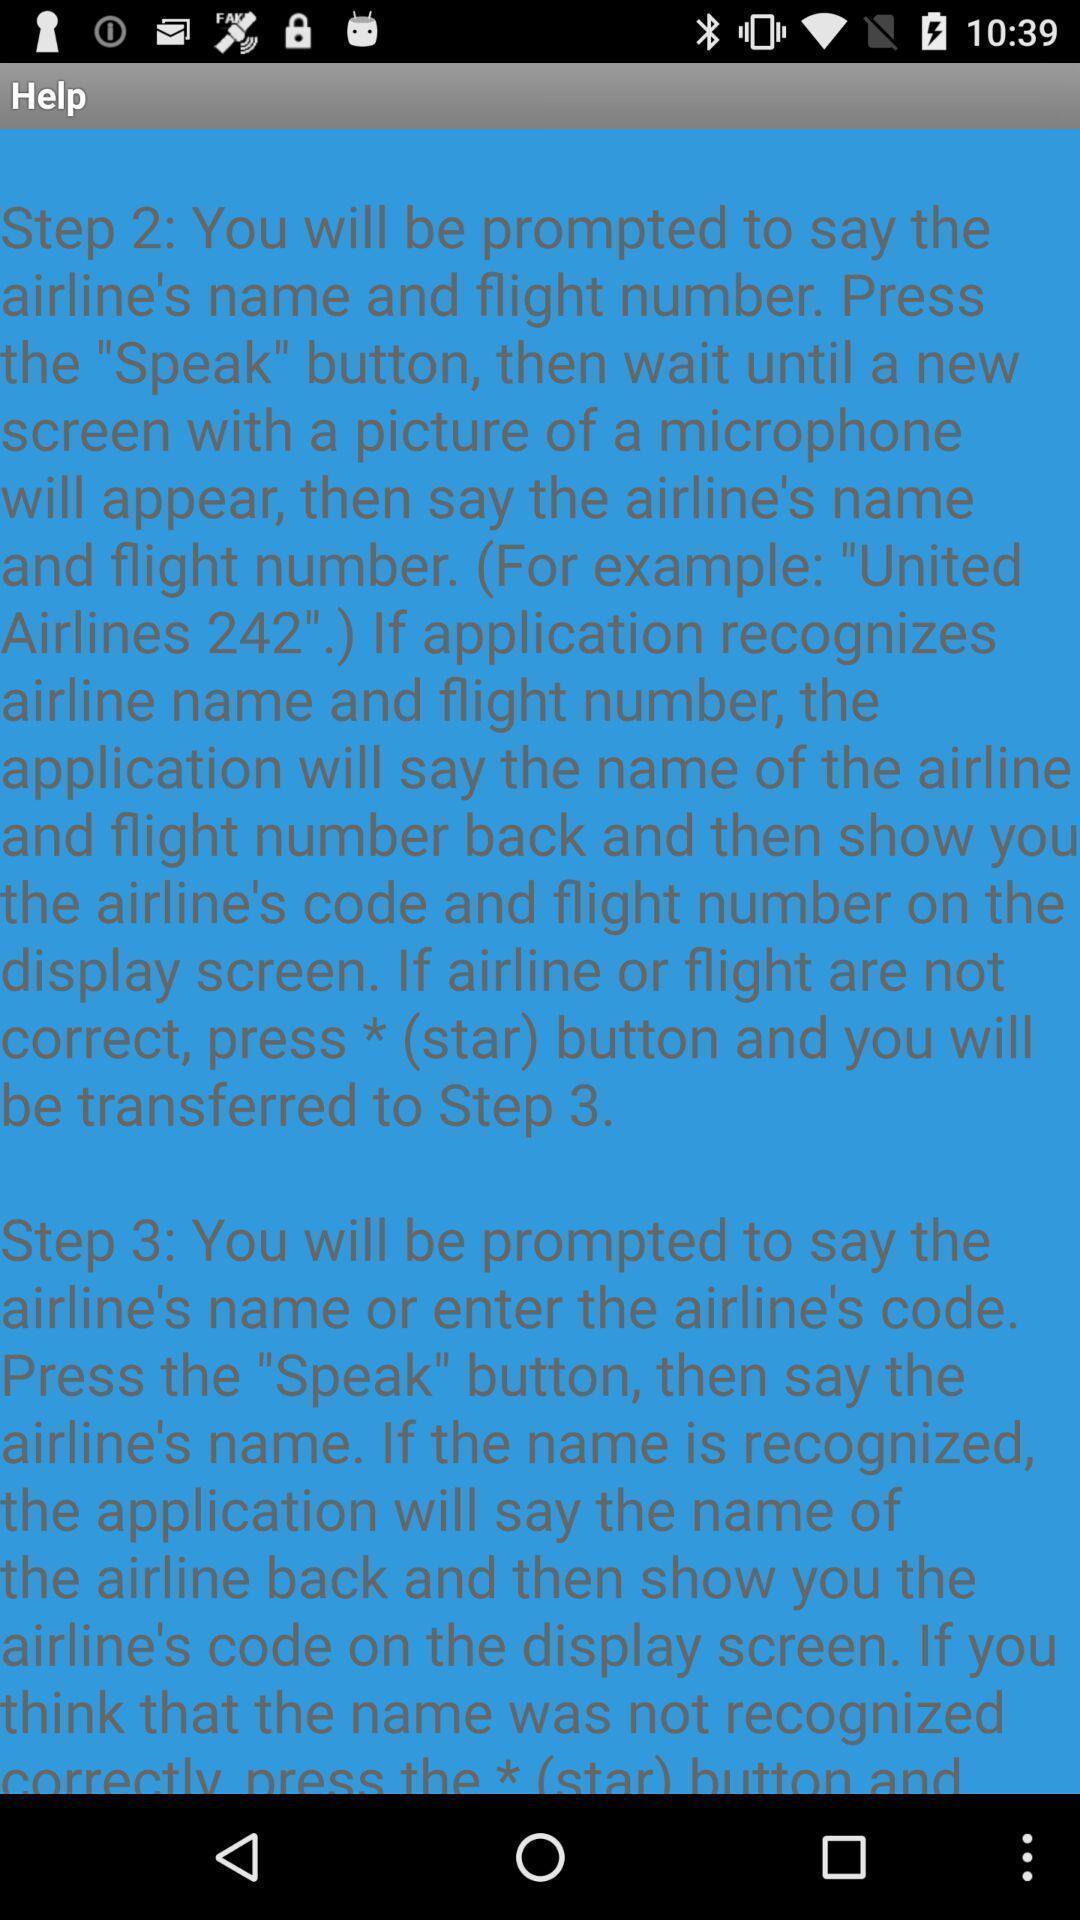Describe the key features of this screenshot. Screen showing steps to track a flight in travel app. 